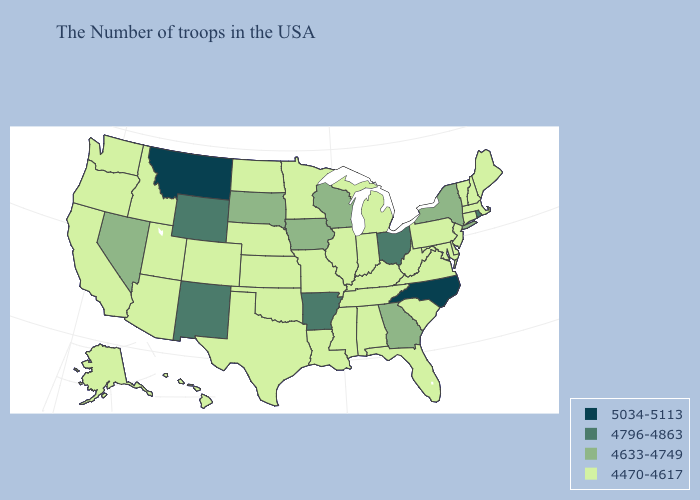Name the states that have a value in the range 5034-5113?
Short answer required. North Carolina, Montana. Which states hav the highest value in the Northeast?
Quick response, please. Rhode Island. What is the highest value in states that border Washington?
Write a very short answer. 4470-4617. Does Idaho have the same value as South Dakota?
Quick response, please. No. Name the states that have a value in the range 5034-5113?
Concise answer only. North Carolina, Montana. Does New Jersey have the highest value in the Northeast?
Quick response, please. No. What is the value of North Dakota?
Write a very short answer. 4470-4617. Name the states that have a value in the range 5034-5113?
Quick response, please. North Carolina, Montana. What is the value of Florida?
Keep it brief. 4470-4617. Does the map have missing data?
Keep it brief. No. Name the states that have a value in the range 5034-5113?
Quick response, please. North Carolina, Montana. Which states hav the highest value in the South?
Be succinct. North Carolina. Does New York have the lowest value in the Northeast?
Be succinct. No. Does Rhode Island have the lowest value in the USA?
Keep it brief. No. What is the value of Maryland?
Short answer required. 4470-4617. 